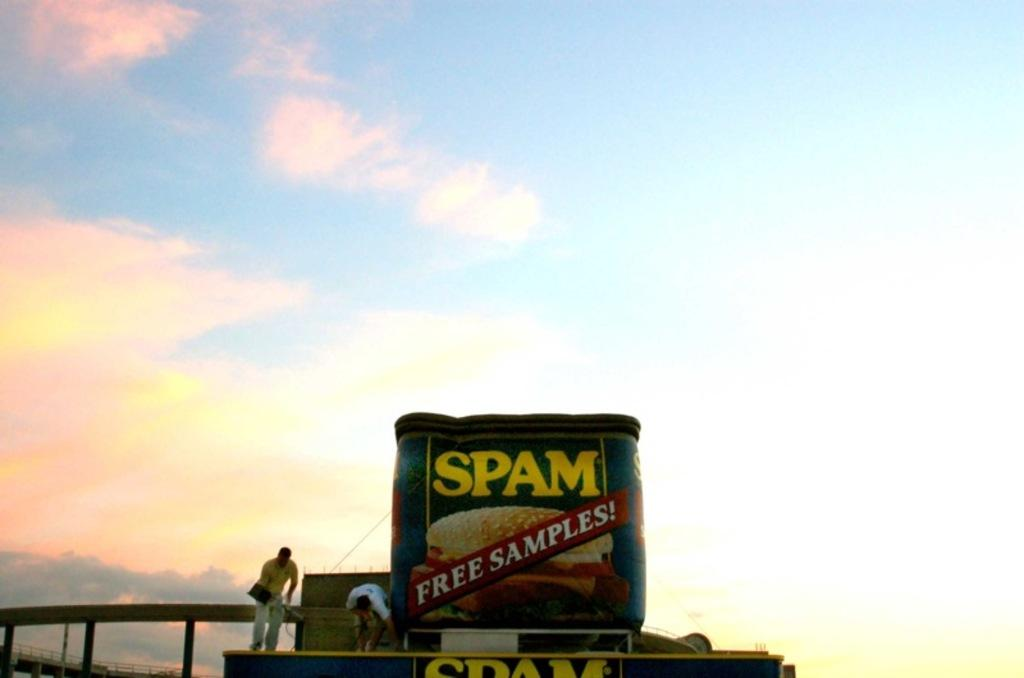<image>
Give a short and clear explanation of the subsequent image. A large can of spam offering free samples outdoors on a cloudy day. 